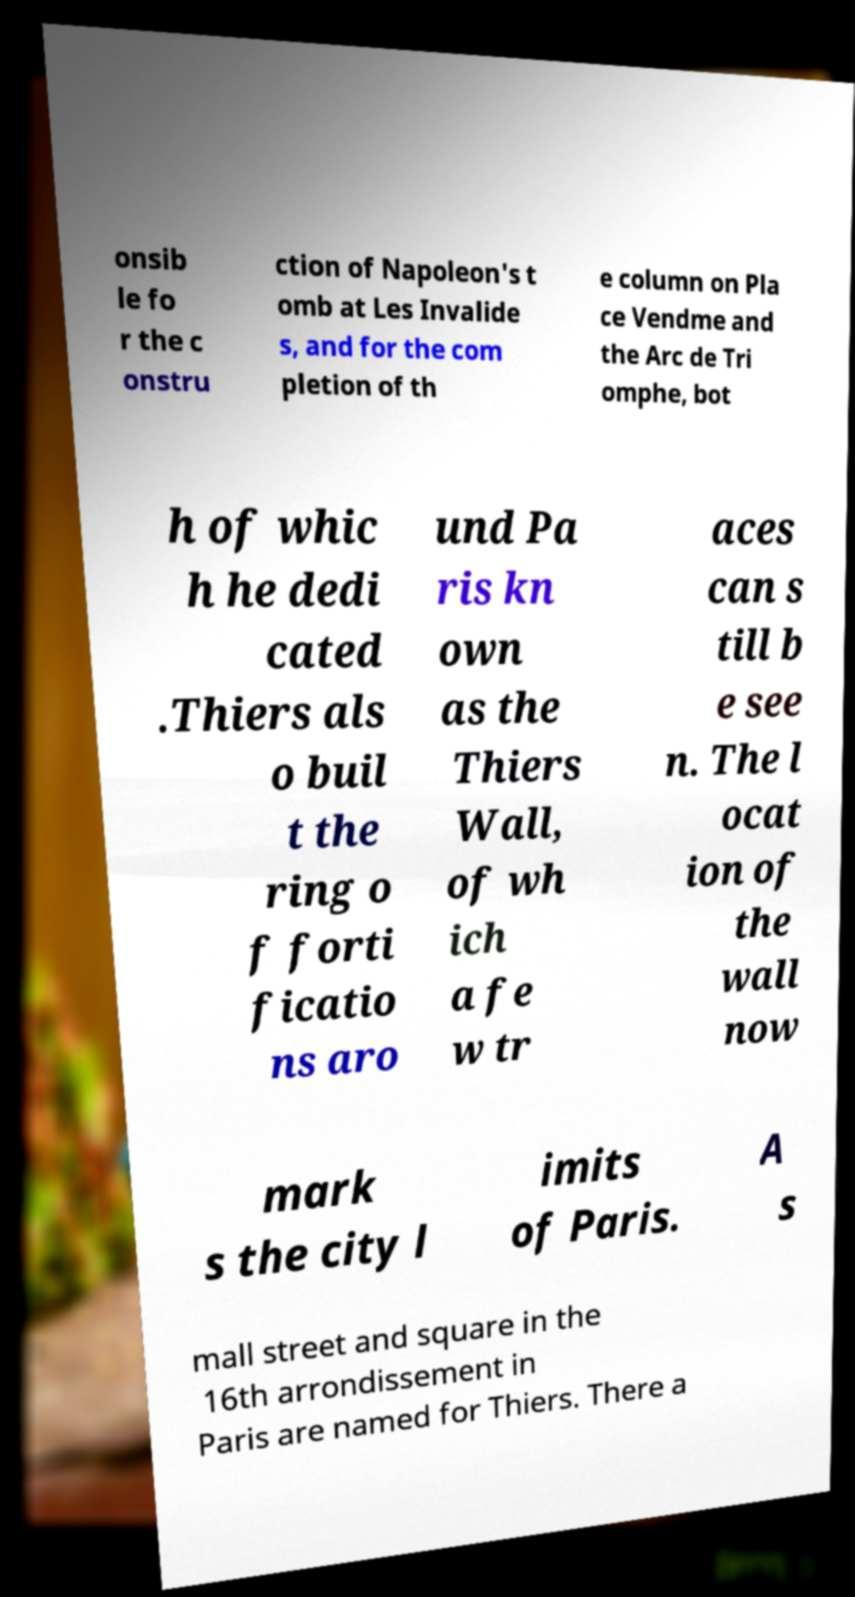What messages or text are displayed in this image? I need them in a readable, typed format. onsib le fo r the c onstru ction of Napoleon's t omb at Les Invalide s, and for the com pletion of th e column on Pla ce Vendme and the Arc de Tri omphe, bot h of whic h he dedi cated .Thiers als o buil t the ring o f forti ficatio ns aro und Pa ris kn own as the Thiers Wall, of wh ich a fe w tr aces can s till b e see n. The l ocat ion of the wall now mark s the city l imits of Paris. A s mall street and square in the 16th arrondissement in Paris are named for Thiers. There a 